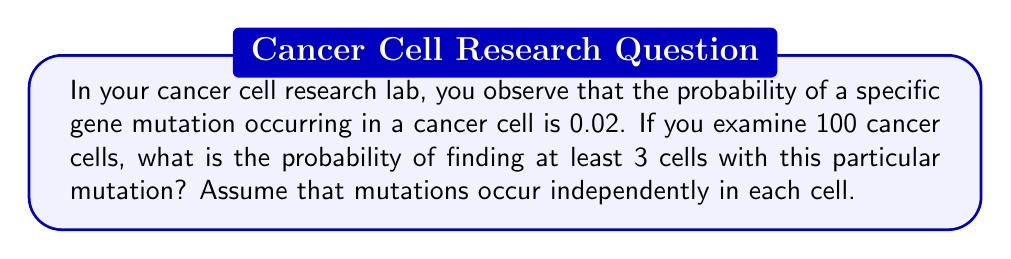Solve this math problem. Let's approach this step-by-step using the binomial distribution and its complement:

1) Let X be the number of cells with the mutation out of 100 cells.

2) X follows a binomial distribution with n = 100 and p = 0.02.

3) We want P(X ≥ 3), which is equivalent to 1 - P(X < 3) or 1 - [P(X = 0) + P(X = 1) + P(X = 2)].

4) The probability mass function for the binomial distribution is:

   $$P(X = k) = \binom{n}{k} p^k (1-p)^{n-k}$$

5) Let's calculate each probability:

   P(X = 0) = $\binom{100}{0} (0.02)^0 (0.98)^{100} = 0.1326$

   P(X = 1) = $\binom{100}{1} (0.02)^1 (0.98)^{99} = 0.2707$

   P(X = 2) = $\binom{100}{2} (0.02)^2 (0.98)^{98} = 0.2734$

6) Sum these probabilities:

   P(X < 3) = 0.1326 + 0.2707 + 0.2734 = 0.6767

7) Therefore, the probability of at least 3 cells with the mutation is:

   P(X ≥ 3) = 1 - P(X < 3) = 1 - 0.6767 = 0.3233
Answer: 0.3233 